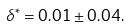<formula> <loc_0><loc_0><loc_500><loc_500>\delta ^ { \ast } = 0 . 0 1 \pm 0 . 0 4 .</formula> 